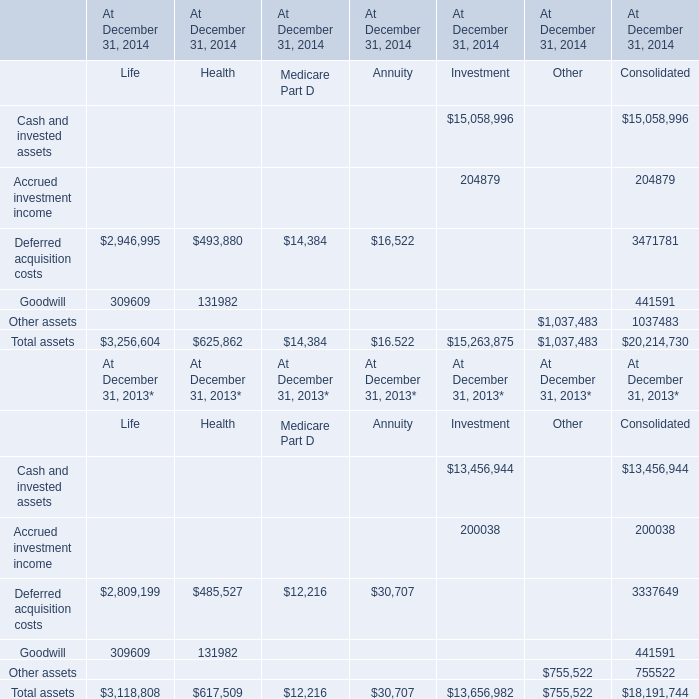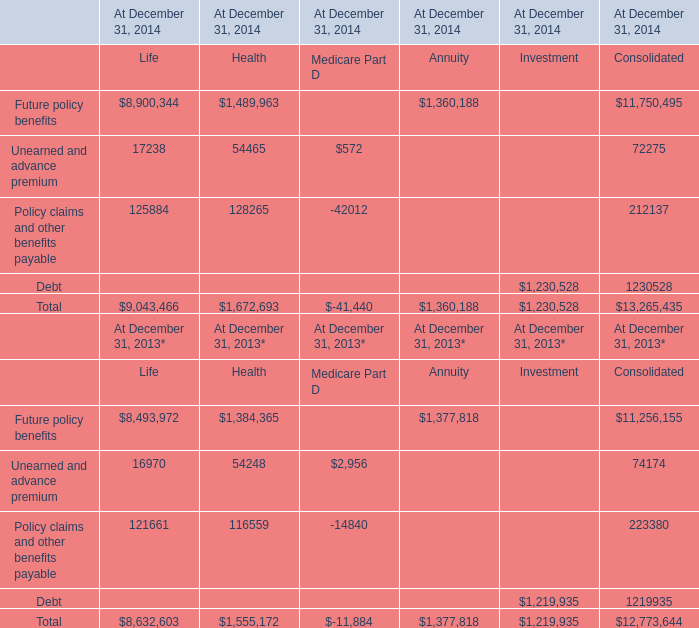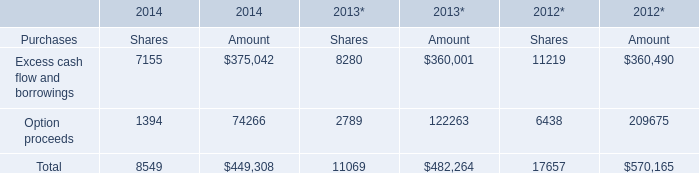What is the total amount of Future policy benefits of At December 31, 2014 Consolidated, and Option proceeds of 2013* Amount ? 
Computations: (11750495.0 + 122263.0)
Answer: 11872758.0. 